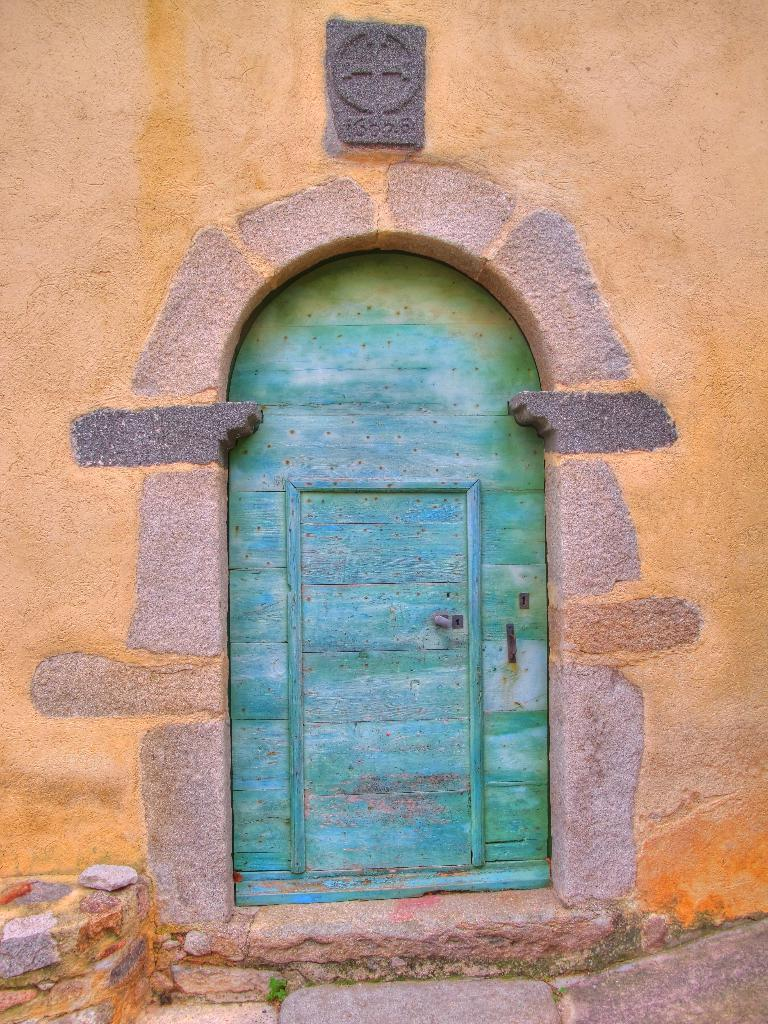What color is the wall in the image? The wall in the image is painted orange. What feature is present in the center of the wall? There is a gate in the center of the wall. What type of surface is visible in the foreground of the image? The foreground appears to be a pavement. What architectural element can be seen on the left side of the image? There is a staircase on the left side of the image. How many brothers are depicted in the image? There are no brothers present in the image. Is there a slave visible in the image? There is no slave present in the image. 